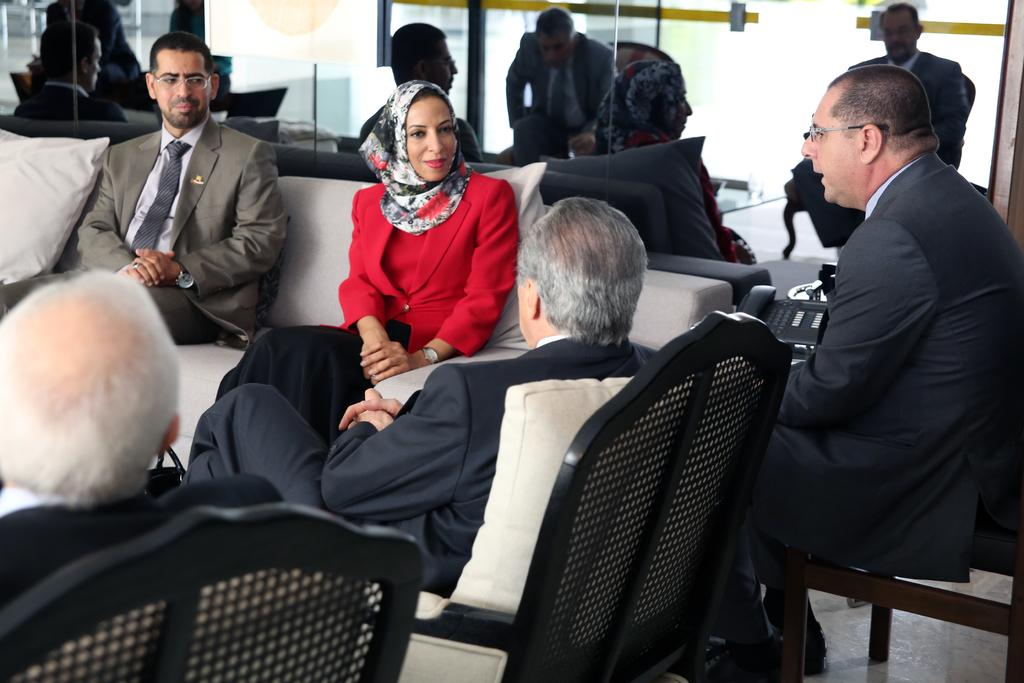Who or what can be seen in the image? There are people in the image. What are the people doing in the image? The people are sitting on a sofa. Are there any other furniture pieces visible in the image? Yes, there is a chair in the image. What type of toy can be seen on the chair in the image? There is no toy visible on the chair in the image. What is the taste of the dolls in the image? There are no dolls present in the image, so their taste cannot be determined. 